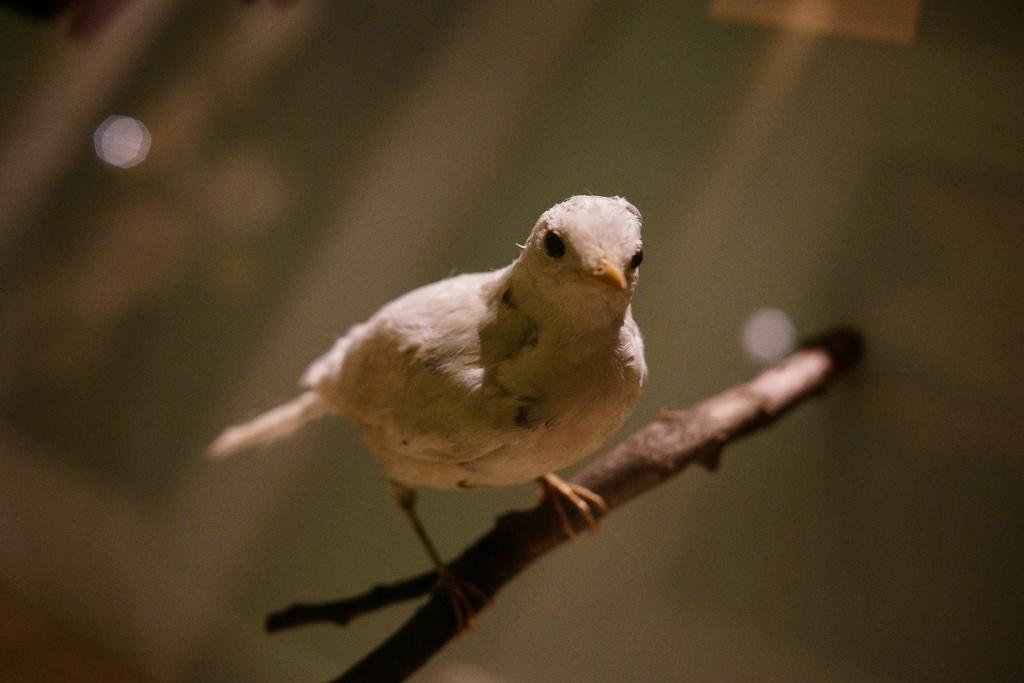What type of animal can be seen in the image? There is a bird in the image. Where is the bird located in the image? The bird is sitting on the branch of a tree. What type of dirt can be seen in the image? There is no dirt present in the image; it features a bird sitting on the branch of a tree. 